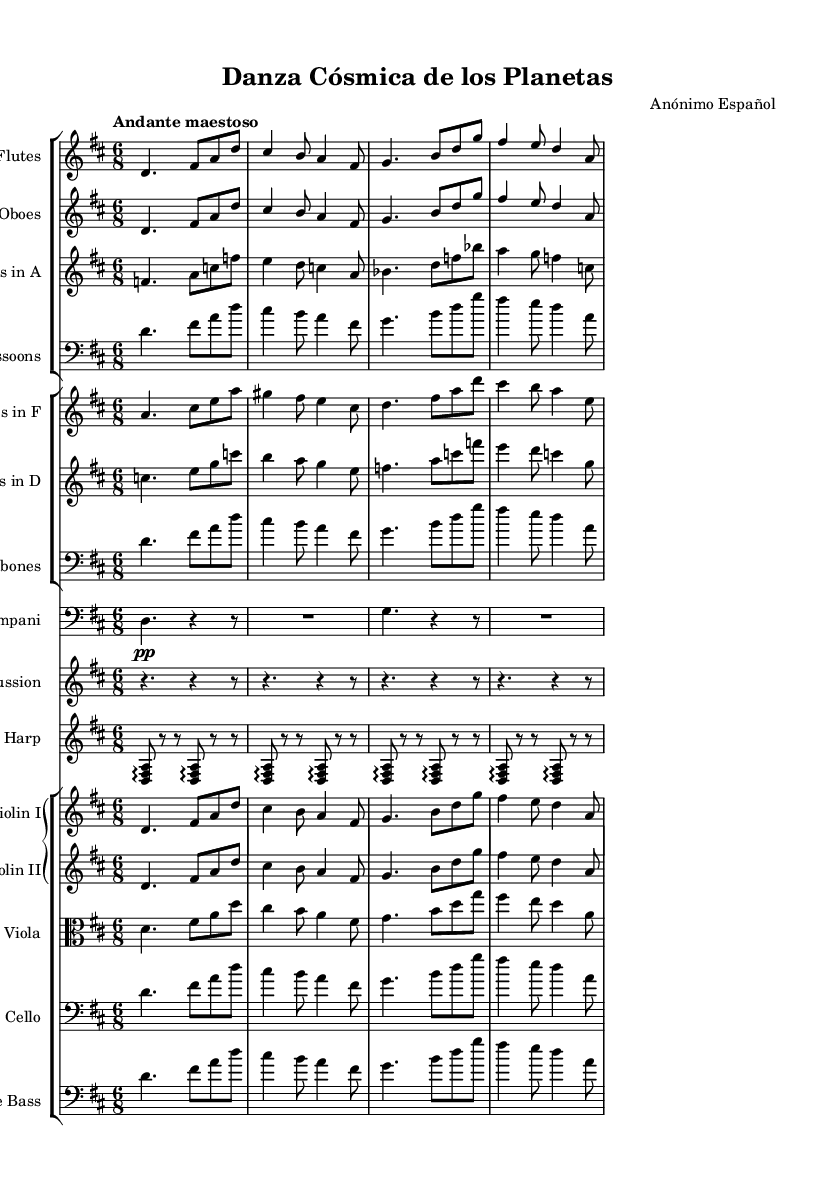What is the key signature of this music? The key signature is marked by the number of sharps or flats at the beginning of the staff. Here, there are two sharps (F# and C#), indicating the key of D major.
Answer: D major What is the time signature of this music? The time signature is found at the beginning of the piece, denoted by the numbers. In this case, it shows 6 over 8, which means there are 6 beats per measure, and the eighth note gets the beat.
Answer: 6/8 What is the tempo marking for this symphony? The tempo marking is often written above the staff at the beginning. Here, it states "Andante maestoso," indicating a moderately slow tempo with a dignified character.
Answer: Andante maestoso How many different instrument groups are present in the music? By examining the score, we can see multiple staff groups for different instrument families. There are woodwinds, brass, percussion, harp, and strings. Counting these gives several distinct groups.
Answer: Four What is the dynamics marking indicated for the timpani? The dynamics for the timpani are given by the abbreviation "pp," which stands for pianissimo, meaning very soft. This is indicated at the beginning of the timpani staff.
Answer: pianissimo Which voices are playing the main theme in this symphony? To identify voices, we look at each staff and see where the main theme is indicated. The theme is presented in flutes, oboes, violins, and cellos. They all perform the same melody together.
Answer: Flutes, Oboes, Violins, Cellos What is unique about the percussion staff in this piece? The percussion staff is denoted by rhythmic notation that specifies no pitched notes, suggesting that it serves a rhythmic complement to the harmonic and melodic structure of the symphony. Furthermore, it has a repeated pattern indicating rhythm emphasis.
Answer: Non-pitched, repeated rhythm 